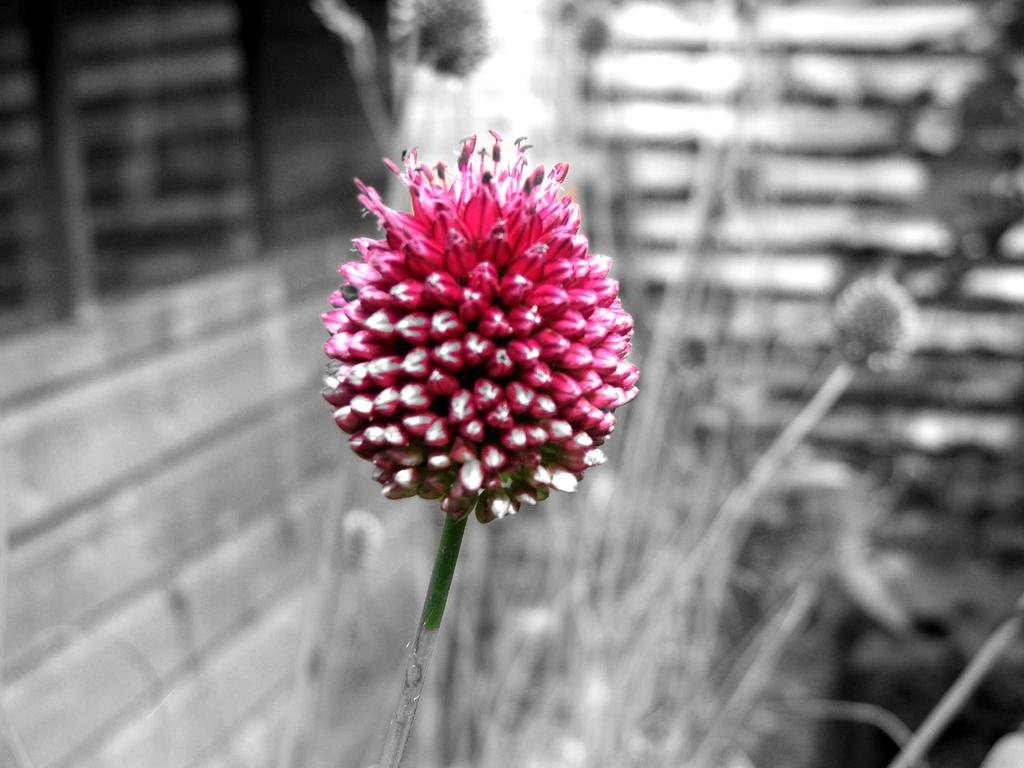What is the main subject of the image? There is a flower in the image. Can you describe the color of the flower? The flower is pink. What can be seen in the background of the image? There is a wall and a plant in the background of the image. How is the background of the image depicted? The background is blurred. Where is the tub located in the image? There is no tub present in the image. Can you describe the type of bear that is interacting with the flower in the image? There is no bear present in the image; it only features a flower and a blurred background. 